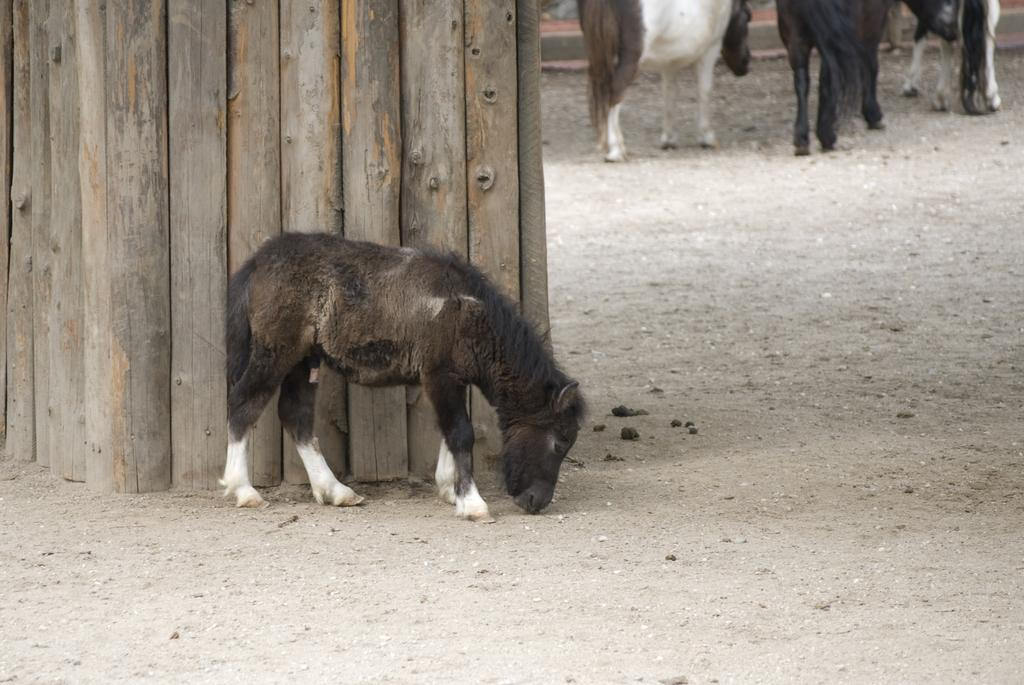What types of living organisms can be seen in the image? There are animals in the image. What colors are the animals in the image? The animals are in brown and white color. What can be seen in the background of the image? There is a wooden door in the background of the image. How many boys are present in the image? There are no boys present in the image; it features animals and a wooden door. What type of furniture can be seen in the image? There is no furniture present in the image; it only features animals and a wooden door. 